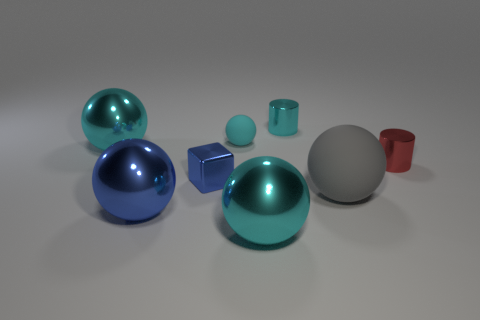Is there anything else that is the same shape as the tiny blue metallic object?
Make the answer very short. No. Do the small sphere and the large cyan thing that is in front of the big rubber thing have the same material?
Ensure brevity in your answer.  No. What number of objects are either tiny red things or metallic objects behind the red object?
Keep it short and to the point. 3. There is a metallic cylinder behind the red shiny object; is its size the same as the metal block that is behind the large gray rubber object?
Keep it short and to the point. Yes. How many other objects are there of the same color as the small rubber ball?
Your answer should be very brief. 3. Does the blue metallic cube have the same size as the cyan cylinder that is to the right of the big blue metallic object?
Your response must be concise. Yes. What is the size of the rubber sphere that is to the right of the large cyan ball on the right side of the small blue metallic cube?
Your answer should be very brief. Large. What color is the other small shiny object that is the same shape as the red object?
Provide a succinct answer. Cyan. Do the gray rubber ball and the blue sphere have the same size?
Offer a very short reply. Yes. Are there the same number of small red metal cylinders in front of the big gray matte object and yellow things?
Provide a succinct answer. Yes. 